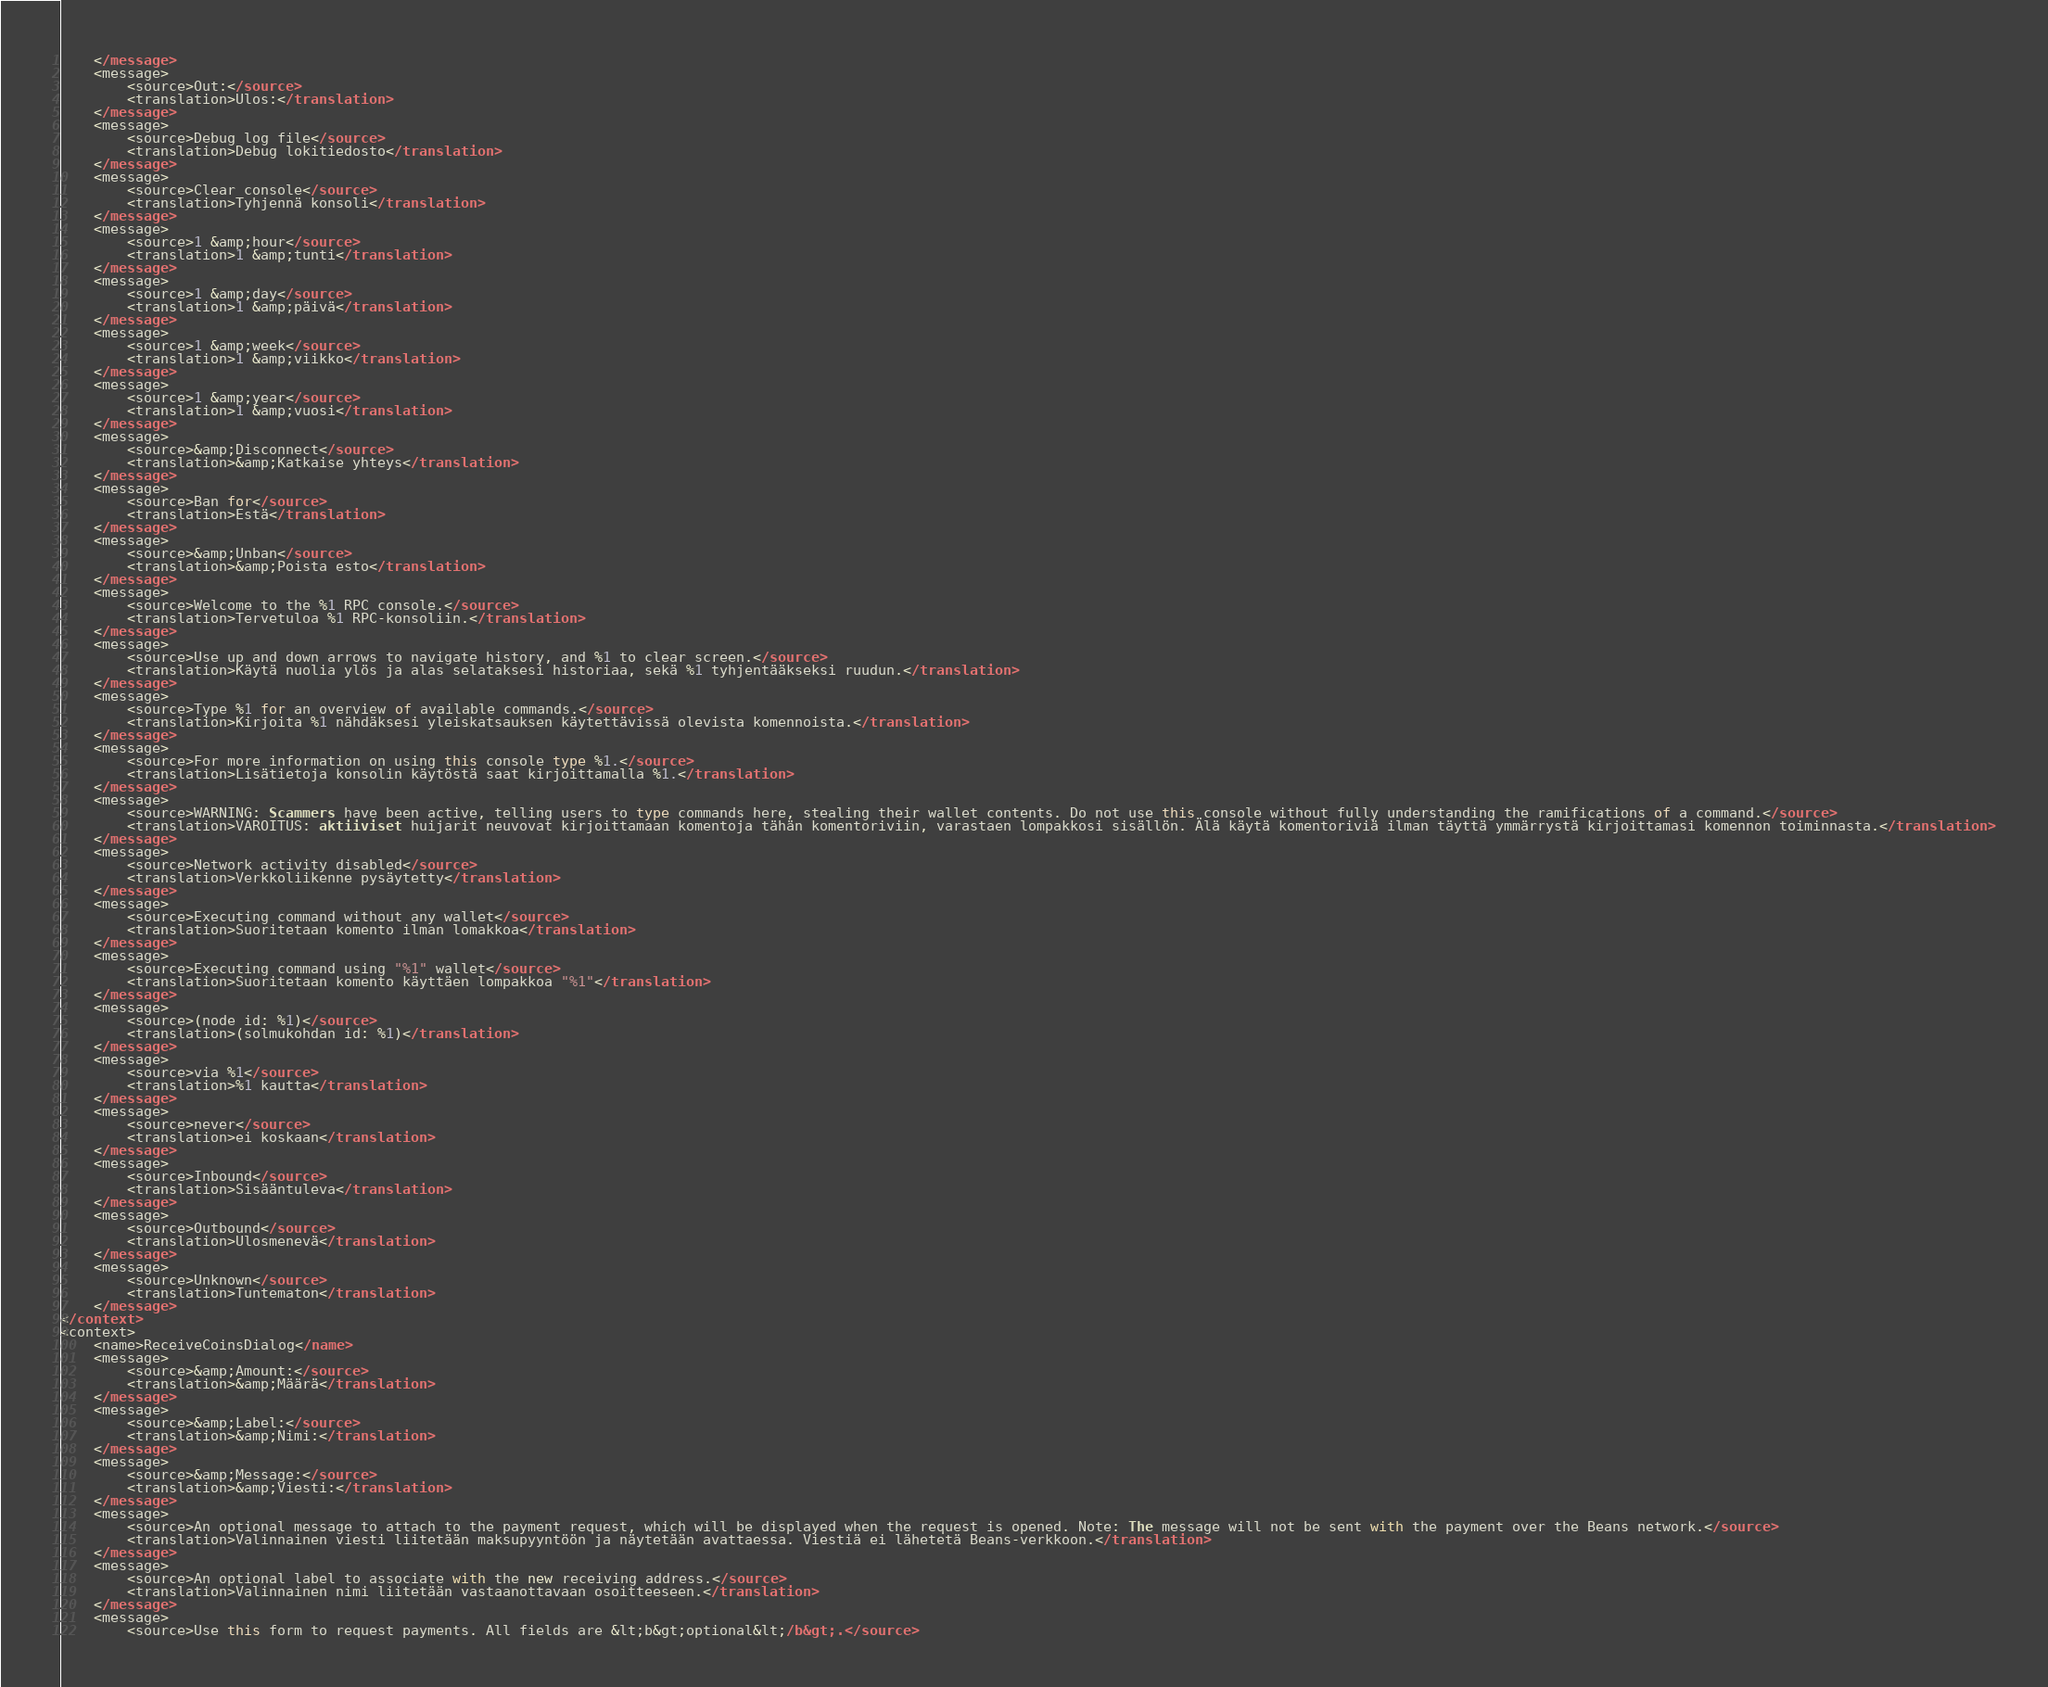Convert code to text. <code><loc_0><loc_0><loc_500><loc_500><_TypeScript_>    </message>
    <message>
        <source>Out:</source>
        <translation>Ulos:</translation>
    </message>
    <message>
        <source>Debug log file</source>
        <translation>Debug lokitiedosto</translation>
    </message>
    <message>
        <source>Clear console</source>
        <translation>Tyhjennä konsoli</translation>
    </message>
    <message>
        <source>1 &amp;hour</source>
        <translation>1 &amp;tunti</translation>
    </message>
    <message>
        <source>1 &amp;day</source>
        <translation>1 &amp;päivä</translation>
    </message>
    <message>
        <source>1 &amp;week</source>
        <translation>1 &amp;viikko</translation>
    </message>
    <message>
        <source>1 &amp;year</source>
        <translation>1 &amp;vuosi</translation>
    </message>
    <message>
        <source>&amp;Disconnect</source>
        <translation>&amp;Katkaise yhteys</translation>
    </message>
    <message>
        <source>Ban for</source>
        <translation>Estä</translation>
    </message>
    <message>
        <source>&amp;Unban</source>
        <translation>&amp;Poista esto</translation>
    </message>
    <message>
        <source>Welcome to the %1 RPC console.</source>
        <translation>Tervetuloa %1 RPC-konsoliin.</translation>
    </message>
    <message>
        <source>Use up and down arrows to navigate history, and %1 to clear screen.</source>
        <translation>Käytä nuolia ylös ja alas selataksesi historiaa, sekä %1 tyhjentääkseksi ruudun.</translation>
    </message>
    <message>
        <source>Type %1 for an overview of available commands.</source>
        <translation>Kirjoita %1 nähdäksesi yleiskatsauksen käytettävissä olevista komennoista.</translation>
    </message>
    <message>
        <source>For more information on using this console type %1.</source>
        <translation>Lisätietoja konsolin käytöstä saat kirjoittamalla %1.</translation>
    </message>
    <message>
        <source>WARNING: Scammers have been active, telling users to type commands here, stealing their wallet contents. Do not use this console without fully understanding the ramifications of a command.</source>
        <translation>VAROITUS: aktiiviset huijarit neuvovat kirjoittamaan komentoja tähän komentoriviin, varastaen lompakkosi sisällön. Älä käytä komentoriviä ilman täyttä ymmärrystä kirjoittamasi komennon toiminnasta.</translation>
    </message>
    <message>
        <source>Network activity disabled</source>
        <translation>Verkkoliikenne pysäytetty</translation>
    </message>
    <message>
        <source>Executing command without any wallet</source>
        <translation>Suoritetaan komento ilman lomakkoa</translation>
    </message>
    <message>
        <source>Executing command using "%1" wallet</source>
        <translation>Suoritetaan komento käyttäen lompakkoa "%1"</translation>
    </message>
    <message>
        <source>(node id: %1)</source>
        <translation>(solmukohdan id: %1)</translation>
    </message>
    <message>
        <source>via %1</source>
        <translation>%1 kautta</translation>
    </message>
    <message>
        <source>never</source>
        <translation>ei koskaan</translation>
    </message>
    <message>
        <source>Inbound</source>
        <translation>Sisääntuleva</translation>
    </message>
    <message>
        <source>Outbound</source>
        <translation>Ulosmenevä</translation>
    </message>
    <message>
        <source>Unknown</source>
        <translation>Tuntematon</translation>
    </message>
</context>
<context>
    <name>ReceiveCoinsDialog</name>
    <message>
        <source>&amp;Amount:</source>
        <translation>&amp;Määrä</translation>
    </message>
    <message>
        <source>&amp;Label:</source>
        <translation>&amp;Nimi:</translation>
    </message>
    <message>
        <source>&amp;Message:</source>
        <translation>&amp;Viesti:</translation>
    </message>
    <message>
        <source>An optional message to attach to the payment request, which will be displayed when the request is opened. Note: The message will not be sent with the payment over the Beans network.</source>
        <translation>Valinnainen viesti liitetään maksupyyntöön ja näytetään avattaessa. Viestiä ei lähetetä Beans-verkkoon.</translation>
    </message>
    <message>
        <source>An optional label to associate with the new receiving address.</source>
        <translation>Valinnainen nimi liitetään vastaanottavaan osoitteeseen.</translation>
    </message>
    <message>
        <source>Use this form to request payments. All fields are &lt;b&gt;optional&lt;/b&gt;.</source></code> 